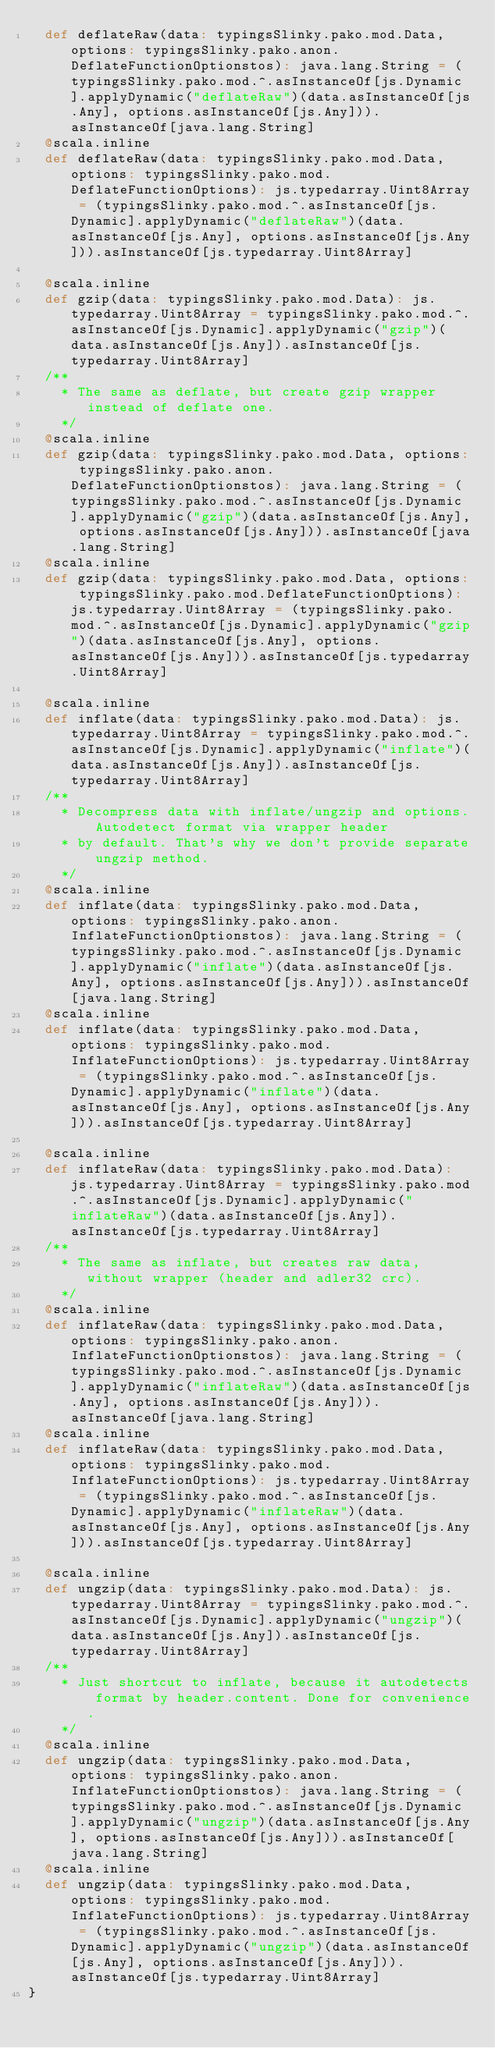<code> <loc_0><loc_0><loc_500><loc_500><_Scala_>  def deflateRaw(data: typingsSlinky.pako.mod.Data, options: typingsSlinky.pako.anon.DeflateFunctionOptionstos): java.lang.String = (typingsSlinky.pako.mod.^.asInstanceOf[js.Dynamic].applyDynamic("deflateRaw")(data.asInstanceOf[js.Any], options.asInstanceOf[js.Any])).asInstanceOf[java.lang.String]
  @scala.inline
  def deflateRaw(data: typingsSlinky.pako.mod.Data, options: typingsSlinky.pako.mod.DeflateFunctionOptions): js.typedarray.Uint8Array = (typingsSlinky.pako.mod.^.asInstanceOf[js.Dynamic].applyDynamic("deflateRaw")(data.asInstanceOf[js.Any], options.asInstanceOf[js.Any])).asInstanceOf[js.typedarray.Uint8Array]
  
  @scala.inline
  def gzip(data: typingsSlinky.pako.mod.Data): js.typedarray.Uint8Array = typingsSlinky.pako.mod.^.asInstanceOf[js.Dynamic].applyDynamic("gzip")(data.asInstanceOf[js.Any]).asInstanceOf[js.typedarray.Uint8Array]
  /**
    * The same as deflate, but create gzip wrapper instead of deflate one.
    */
  @scala.inline
  def gzip(data: typingsSlinky.pako.mod.Data, options: typingsSlinky.pako.anon.DeflateFunctionOptionstos): java.lang.String = (typingsSlinky.pako.mod.^.asInstanceOf[js.Dynamic].applyDynamic("gzip")(data.asInstanceOf[js.Any], options.asInstanceOf[js.Any])).asInstanceOf[java.lang.String]
  @scala.inline
  def gzip(data: typingsSlinky.pako.mod.Data, options: typingsSlinky.pako.mod.DeflateFunctionOptions): js.typedarray.Uint8Array = (typingsSlinky.pako.mod.^.asInstanceOf[js.Dynamic].applyDynamic("gzip")(data.asInstanceOf[js.Any], options.asInstanceOf[js.Any])).asInstanceOf[js.typedarray.Uint8Array]
  
  @scala.inline
  def inflate(data: typingsSlinky.pako.mod.Data): js.typedarray.Uint8Array = typingsSlinky.pako.mod.^.asInstanceOf[js.Dynamic].applyDynamic("inflate")(data.asInstanceOf[js.Any]).asInstanceOf[js.typedarray.Uint8Array]
  /**
    * Decompress data with inflate/ungzip and options. Autodetect format via wrapper header
    * by default. That's why we don't provide separate ungzip method.
    */
  @scala.inline
  def inflate(data: typingsSlinky.pako.mod.Data, options: typingsSlinky.pako.anon.InflateFunctionOptionstos): java.lang.String = (typingsSlinky.pako.mod.^.asInstanceOf[js.Dynamic].applyDynamic("inflate")(data.asInstanceOf[js.Any], options.asInstanceOf[js.Any])).asInstanceOf[java.lang.String]
  @scala.inline
  def inflate(data: typingsSlinky.pako.mod.Data, options: typingsSlinky.pako.mod.InflateFunctionOptions): js.typedarray.Uint8Array = (typingsSlinky.pako.mod.^.asInstanceOf[js.Dynamic].applyDynamic("inflate")(data.asInstanceOf[js.Any], options.asInstanceOf[js.Any])).asInstanceOf[js.typedarray.Uint8Array]
  
  @scala.inline
  def inflateRaw(data: typingsSlinky.pako.mod.Data): js.typedarray.Uint8Array = typingsSlinky.pako.mod.^.asInstanceOf[js.Dynamic].applyDynamic("inflateRaw")(data.asInstanceOf[js.Any]).asInstanceOf[js.typedarray.Uint8Array]
  /**
    * The same as inflate, but creates raw data, without wrapper (header and adler32 crc).
    */
  @scala.inline
  def inflateRaw(data: typingsSlinky.pako.mod.Data, options: typingsSlinky.pako.anon.InflateFunctionOptionstos): java.lang.String = (typingsSlinky.pako.mod.^.asInstanceOf[js.Dynamic].applyDynamic("inflateRaw")(data.asInstanceOf[js.Any], options.asInstanceOf[js.Any])).asInstanceOf[java.lang.String]
  @scala.inline
  def inflateRaw(data: typingsSlinky.pako.mod.Data, options: typingsSlinky.pako.mod.InflateFunctionOptions): js.typedarray.Uint8Array = (typingsSlinky.pako.mod.^.asInstanceOf[js.Dynamic].applyDynamic("inflateRaw")(data.asInstanceOf[js.Any], options.asInstanceOf[js.Any])).asInstanceOf[js.typedarray.Uint8Array]
  
  @scala.inline
  def ungzip(data: typingsSlinky.pako.mod.Data): js.typedarray.Uint8Array = typingsSlinky.pako.mod.^.asInstanceOf[js.Dynamic].applyDynamic("ungzip")(data.asInstanceOf[js.Any]).asInstanceOf[js.typedarray.Uint8Array]
  /**
    * Just shortcut to inflate, because it autodetects format by header.content. Done for convenience.
    */
  @scala.inline
  def ungzip(data: typingsSlinky.pako.mod.Data, options: typingsSlinky.pako.anon.InflateFunctionOptionstos): java.lang.String = (typingsSlinky.pako.mod.^.asInstanceOf[js.Dynamic].applyDynamic("ungzip")(data.asInstanceOf[js.Any], options.asInstanceOf[js.Any])).asInstanceOf[java.lang.String]
  @scala.inline
  def ungzip(data: typingsSlinky.pako.mod.Data, options: typingsSlinky.pako.mod.InflateFunctionOptions): js.typedarray.Uint8Array = (typingsSlinky.pako.mod.^.asInstanceOf[js.Dynamic].applyDynamic("ungzip")(data.asInstanceOf[js.Any], options.asInstanceOf[js.Any])).asInstanceOf[js.typedarray.Uint8Array]
}
</code> 